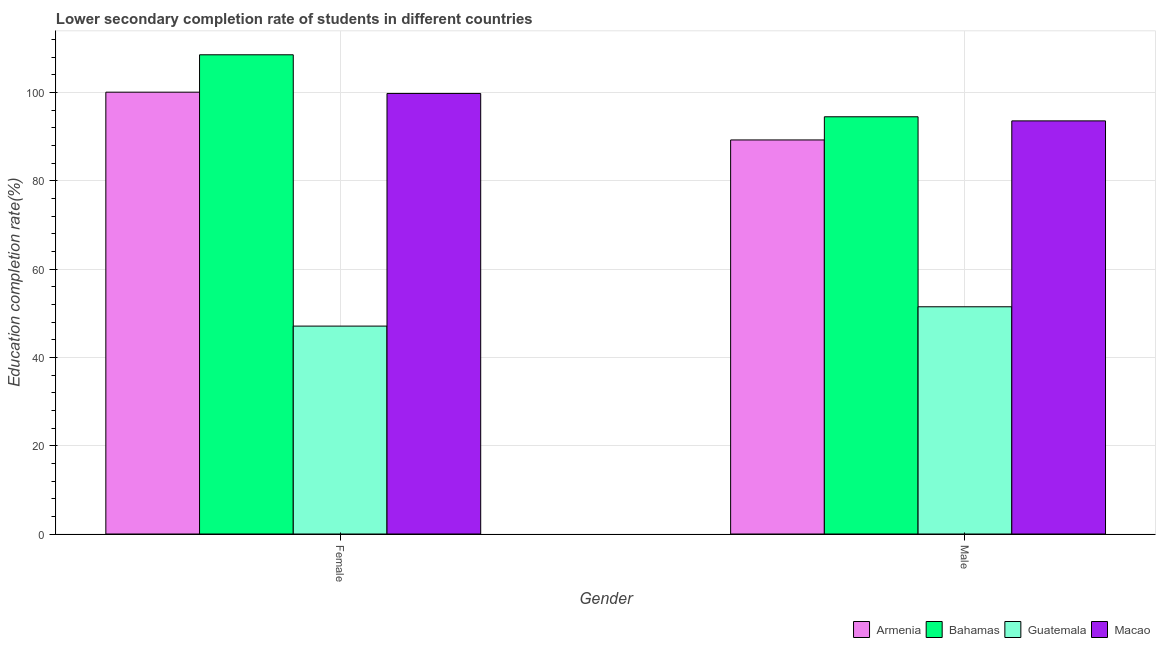Are the number of bars per tick equal to the number of legend labels?
Your answer should be compact. Yes. How many bars are there on the 2nd tick from the right?
Your response must be concise. 4. What is the label of the 1st group of bars from the left?
Your answer should be very brief. Female. What is the education completion rate of male students in Bahamas?
Provide a succinct answer. 94.47. Across all countries, what is the maximum education completion rate of male students?
Ensure brevity in your answer.  94.47. Across all countries, what is the minimum education completion rate of male students?
Offer a terse response. 51.45. In which country was the education completion rate of female students maximum?
Offer a very short reply. Bahamas. In which country was the education completion rate of male students minimum?
Offer a terse response. Guatemala. What is the total education completion rate of male students in the graph?
Your answer should be compact. 328.67. What is the difference between the education completion rate of male students in Bahamas and that in Armenia?
Offer a terse response. 5.25. What is the difference between the education completion rate of female students in Macao and the education completion rate of male students in Armenia?
Provide a short and direct response. 10.53. What is the average education completion rate of male students per country?
Keep it short and to the point. 82.17. What is the difference between the education completion rate of male students and education completion rate of female students in Guatemala?
Keep it short and to the point. 4.38. In how many countries, is the education completion rate of male students greater than 20 %?
Give a very brief answer. 4. What is the ratio of the education completion rate of male students in Armenia to that in Bahamas?
Ensure brevity in your answer.  0.94. In how many countries, is the education completion rate of female students greater than the average education completion rate of female students taken over all countries?
Your answer should be very brief. 3. What does the 3rd bar from the left in Male represents?
Ensure brevity in your answer.  Guatemala. What does the 3rd bar from the right in Female represents?
Your response must be concise. Bahamas. How many bars are there?
Provide a succinct answer. 8. How many countries are there in the graph?
Your answer should be very brief. 4. What is the difference between two consecutive major ticks on the Y-axis?
Your answer should be very brief. 20. What is the title of the graph?
Provide a short and direct response. Lower secondary completion rate of students in different countries. Does "Isle of Man" appear as one of the legend labels in the graph?
Make the answer very short. No. What is the label or title of the X-axis?
Your answer should be compact. Gender. What is the label or title of the Y-axis?
Offer a very short reply. Education completion rate(%). What is the Education completion rate(%) in Armenia in Female?
Keep it short and to the point. 100.04. What is the Education completion rate(%) of Bahamas in Female?
Offer a very short reply. 108.5. What is the Education completion rate(%) of Guatemala in Female?
Provide a succinct answer. 47.07. What is the Education completion rate(%) of Macao in Female?
Provide a succinct answer. 99.75. What is the Education completion rate(%) in Armenia in Male?
Your response must be concise. 89.22. What is the Education completion rate(%) in Bahamas in Male?
Keep it short and to the point. 94.47. What is the Education completion rate(%) in Guatemala in Male?
Provide a succinct answer. 51.45. What is the Education completion rate(%) of Macao in Male?
Your answer should be very brief. 93.54. Across all Gender, what is the maximum Education completion rate(%) in Armenia?
Give a very brief answer. 100.04. Across all Gender, what is the maximum Education completion rate(%) in Bahamas?
Offer a terse response. 108.5. Across all Gender, what is the maximum Education completion rate(%) of Guatemala?
Give a very brief answer. 51.45. Across all Gender, what is the maximum Education completion rate(%) of Macao?
Provide a succinct answer. 99.75. Across all Gender, what is the minimum Education completion rate(%) in Armenia?
Keep it short and to the point. 89.22. Across all Gender, what is the minimum Education completion rate(%) of Bahamas?
Offer a very short reply. 94.47. Across all Gender, what is the minimum Education completion rate(%) in Guatemala?
Provide a short and direct response. 47.07. Across all Gender, what is the minimum Education completion rate(%) of Macao?
Give a very brief answer. 93.54. What is the total Education completion rate(%) of Armenia in the graph?
Give a very brief answer. 189.26. What is the total Education completion rate(%) in Bahamas in the graph?
Your answer should be compact. 202.97. What is the total Education completion rate(%) in Guatemala in the graph?
Provide a succinct answer. 98.52. What is the total Education completion rate(%) of Macao in the graph?
Your response must be concise. 193.28. What is the difference between the Education completion rate(%) in Armenia in Female and that in Male?
Provide a short and direct response. 10.81. What is the difference between the Education completion rate(%) in Bahamas in Female and that in Male?
Your answer should be compact. 14.04. What is the difference between the Education completion rate(%) in Guatemala in Female and that in Male?
Make the answer very short. -4.38. What is the difference between the Education completion rate(%) of Macao in Female and that in Male?
Make the answer very short. 6.21. What is the difference between the Education completion rate(%) of Armenia in Female and the Education completion rate(%) of Bahamas in Male?
Make the answer very short. 5.57. What is the difference between the Education completion rate(%) of Armenia in Female and the Education completion rate(%) of Guatemala in Male?
Offer a terse response. 48.59. What is the difference between the Education completion rate(%) in Armenia in Female and the Education completion rate(%) in Macao in Male?
Ensure brevity in your answer.  6.5. What is the difference between the Education completion rate(%) of Bahamas in Female and the Education completion rate(%) of Guatemala in Male?
Keep it short and to the point. 57.05. What is the difference between the Education completion rate(%) of Bahamas in Female and the Education completion rate(%) of Macao in Male?
Give a very brief answer. 14.96. What is the difference between the Education completion rate(%) in Guatemala in Female and the Education completion rate(%) in Macao in Male?
Provide a succinct answer. -46.47. What is the average Education completion rate(%) of Armenia per Gender?
Keep it short and to the point. 94.63. What is the average Education completion rate(%) in Bahamas per Gender?
Your answer should be compact. 101.48. What is the average Education completion rate(%) in Guatemala per Gender?
Offer a terse response. 49.26. What is the average Education completion rate(%) of Macao per Gender?
Provide a short and direct response. 96.64. What is the difference between the Education completion rate(%) in Armenia and Education completion rate(%) in Bahamas in Female?
Your answer should be compact. -8.47. What is the difference between the Education completion rate(%) of Armenia and Education completion rate(%) of Guatemala in Female?
Provide a short and direct response. 52.96. What is the difference between the Education completion rate(%) in Armenia and Education completion rate(%) in Macao in Female?
Keep it short and to the point. 0.29. What is the difference between the Education completion rate(%) in Bahamas and Education completion rate(%) in Guatemala in Female?
Make the answer very short. 61.43. What is the difference between the Education completion rate(%) in Bahamas and Education completion rate(%) in Macao in Female?
Your response must be concise. 8.75. What is the difference between the Education completion rate(%) in Guatemala and Education completion rate(%) in Macao in Female?
Your answer should be compact. -52.68. What is the difference between the Education completion rate(%) in Armenia and Education completion rate(%) in Bahamas in Male?
Give a very brief answer. -5.25. What is the difference between the Education completion rate(%) of Armenia and Education completion rate(%) of Guatemala in Male?
Give a very brief answer. 37.77. What is the difference between the Education completion rate(%) of Armenia and Education completion rate(%) of Macao in Male?
Ensure brevity in your answer.  -4.32. What is the difference between the Education completion rate(%) of Bahamas and Education completion rate(%) of Guatemala in Male?
Offer a terse response. 43.02. What is the difference between the Education completion rate(%) in Bahamas and Education completion rate(%) in Macao in Male?
Offer a terse response. 0.93. What is the difference between the Education completion rate(%) of Guatemala and Education completion rate(%) of Macao in Male?
Offer a terse response. -42.09. What is the ratio of the Education completion rate(%) of Armenia in Female to that in Male?
Provide a short and direct response. 1.12. What is the ratio of the Education completion rate(%) of Bahamas in Female to that in Male?
Provide a succinct answer. 1.15. What is the ratio of the Education completion rate(%) in Guatemala in Female to that in Male?
Keep it short and to the point. 0.91. What is the ratio of the Education completion rate(%) of Macao in Female to that in Male?
Provide a succinct answer. 1.07. What is the difference between the highest and the second highest Education completion rate(%) in Armenia?
Offer a very short reply. 10.81. What is the difference between the highest and the second highest Education completion rate(%) in Bahamas?
Make the answer very short. 14.04. What is the difference between the highest and the second highest Education completion rate(%) in Guatemala?
Your answer should be compact. 4.38. What is the difference between the highest and the second highest Education completion rate(%) of Macao?
Keep it short and to the point. 6.21. What is the difference between the highest and the lowest Education completion rate(%) of Armenia?
Offer a very short reply. 10.81. What is the difference between the highest and the lowest Education completion rate(%) of Bahamas?
Your response must be concise. 14.04. What is the difference between the highest and the lowest Education completion rate(%) of Guatemala?
Offer a terse response. 4.38. What is the difference between the highest and the lowest Education completion rate(%) of Macao?
Ensure brevity in your answer.  6.21. 